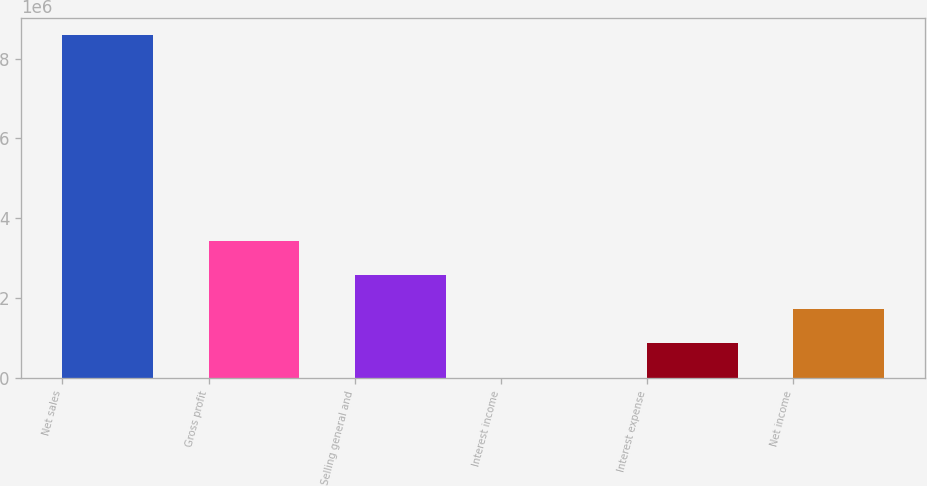<chart> <loc_0><loc_0><loc_500><loc_500><bar_chart><fcel>Net sales<fcel>Gross profit<fcel>Selling general and<fcel>Interest income<fcel>Interest expense<fcel>Net income<nl><fcel>8.58224e+06<fcel>3.4332e+06<fcel>2.57503e+06<fcel>509<fcel>858682<fcel>1.71685e+06<nl></chart> 